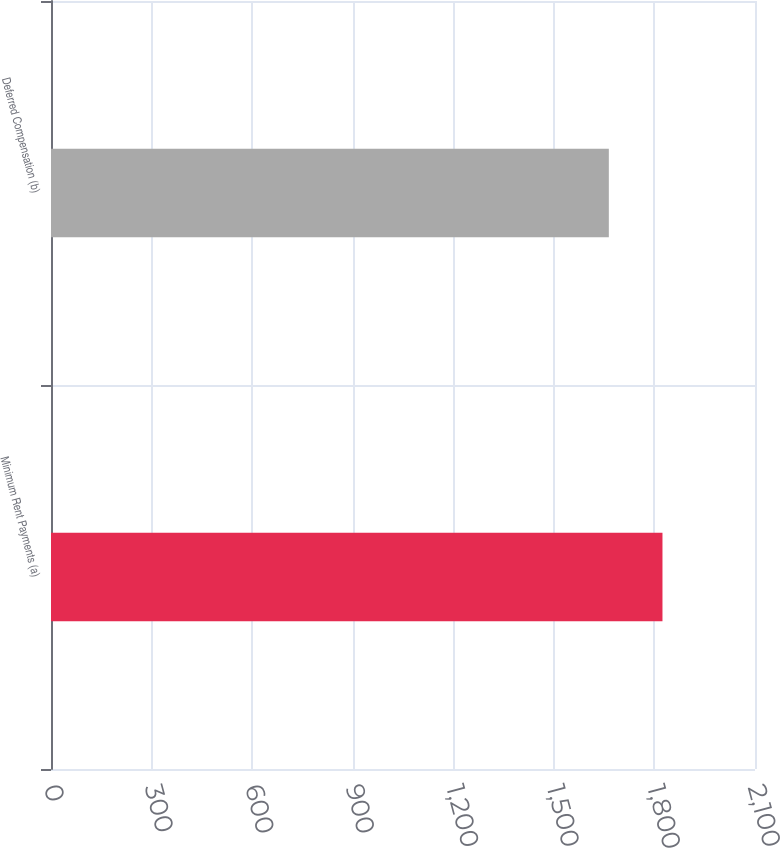<chart> <loc_0><loc_0><loc_500><loc_500><bar_chart><fcel>Minimum Rent Payments (a)<fcel>Deferred Compensation (b)<nl><fcel>1824<fcel>1664<nl></chart> 